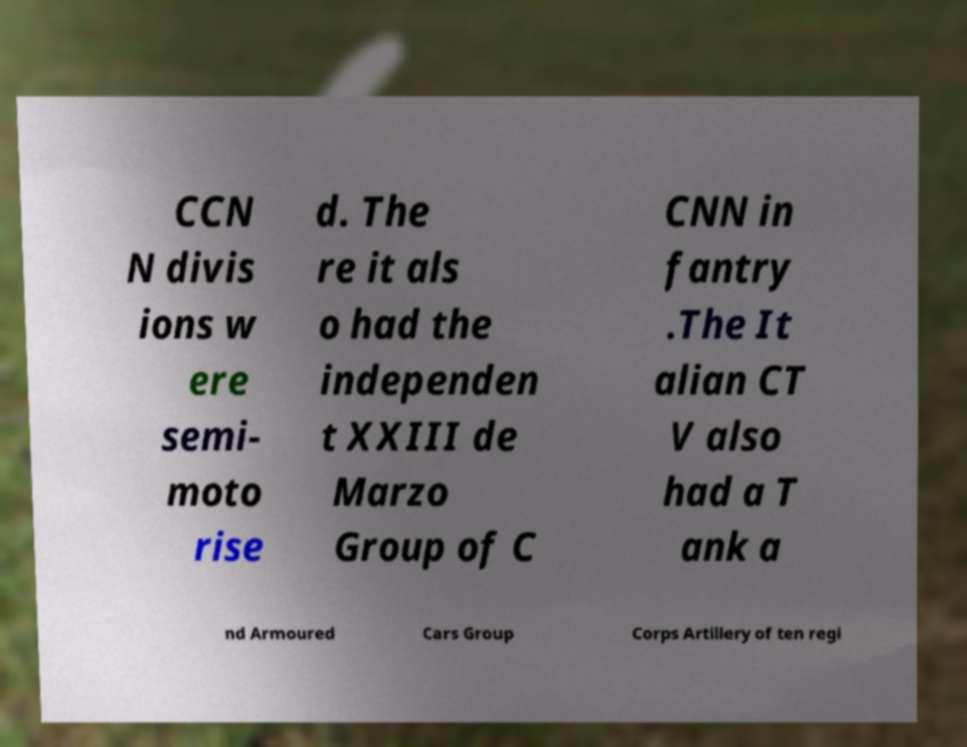What messages or text are displayed in this image? I need them in a readable, typed format. CCN N divis ions w ere semi- moto rise d. The re it als o had the independen t XXIII de Marzo Group of C CNN in fantry .The It alian CT V also had a T ank a nd Armoured Cars Group Corps Artillery of ten regi 